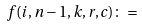<formula> <loc_0><loc_0><loc_500><loc_500>f ( i , n - 1 , k , r , c ) \colon =</formula> 